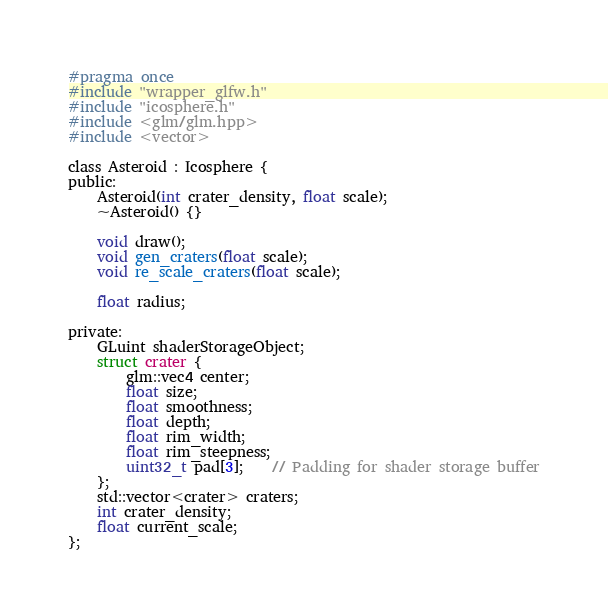Convert code to text. <code><loc_0><loc_0><loc_500><loc_500><_C_>#pragma once
#include "wrapper_glfw.h"
#include "icosphere.h"
#include <glm/glm.hpp>
#include <vector>

class Asteroid : Icosphere {
public:
	Asteroid(int crater_density, float scale);
	~Asteroid() {}

	void draw();
	void gen_craters(float scale);
	void re_scale_craters(float scale);

	float radius;

private:
	GLuint shaderStorageObject;
	struct crater {
		glm::vec4 center;
		float size;
		float smoothness;
		float depth;
		float rim_width;
		float rim_steepness;
		uint32_t pad[3];    // Padding for shader storage buffer
	};
	std::vector<crater> craters;
	int crater_density;
	float current_scale;
};
</code> 